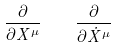<formula> <loc_0><loc_0><loc_500><loc_500>\frac { \partial } { \partial X ^ { \mu } } \quad \frac { \partial } { \partial \dot { X } ^ { \mu } }</formula> 